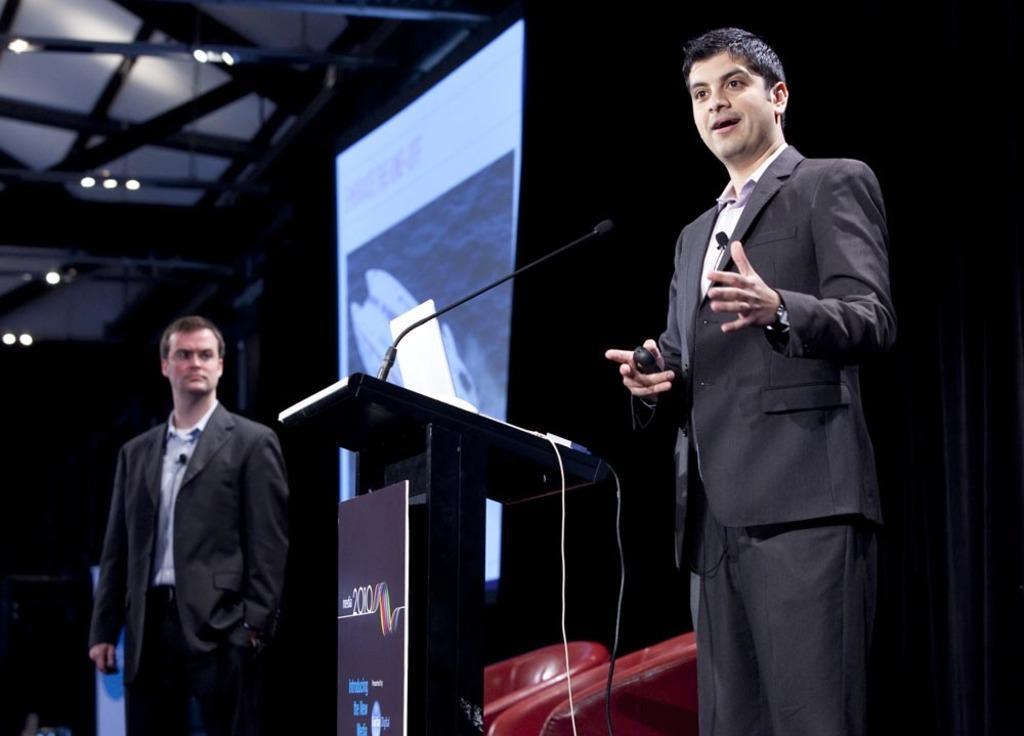How would you summarize this image in a sentence or two? This image is taken indoors. In this image the background is dark and there is a projector screen. At the top of the image there is a roof with a few lights and iron bars. On the left side of the image a man is standing on the dais. In the middle of the image there is a podium with a mic and there is a board with a text on it. There is a laptop on the podium. There are a few empty chairs and a man is standing and he is holding a remote in his hands. 